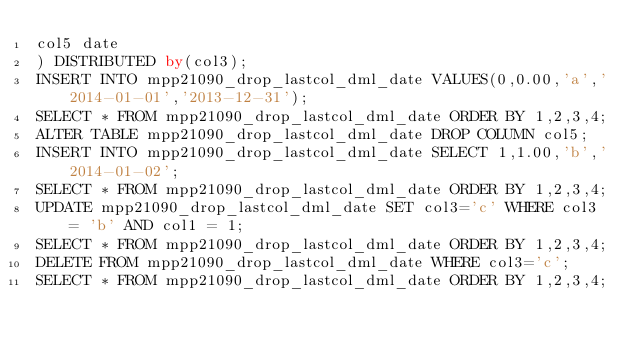Convert code to text. <code><loc_0><loc_0><loc_500><loc_500><_SQL_>col5 date
) DISTRIBUTED by(col3);
INSERT INTO mpp21090_drop_lastcol_dml_date VALUES(0,0.00,'a','2014-01-01','2013-12-31');
SELECT * FROM mpp21090_drop_lastcol_dml_date ORDER BY 1,2,3,4;
ALTER TABLE mpp21090_drop_lastcol_dml_date DROP COLUMN col5;
INSERT INTO mpp21090_drop_lastcol_dml_date SELECT 1,1.00,'b','2014-01-02';
SELECT * FROM mpp21090_drop_lastcol_dml_date ORDER BY 1,2,3,4;
UPDATE mpp21090_drop_lastcol_dml_date SET col3='c' WHERE col3 = 'b' AND col1 = 1;
SELECT * FROM mpp21090_drop_lastcol_dml_date ORDER BY 1,2,3,4;
DELETE FROM mpp21090_drop_lastcol_dml_date WHERE col3='c';
SELECT * FROM mpp21090_drop_lastcol_dml_date ORDER BY 1,2,3,4;

</code> 